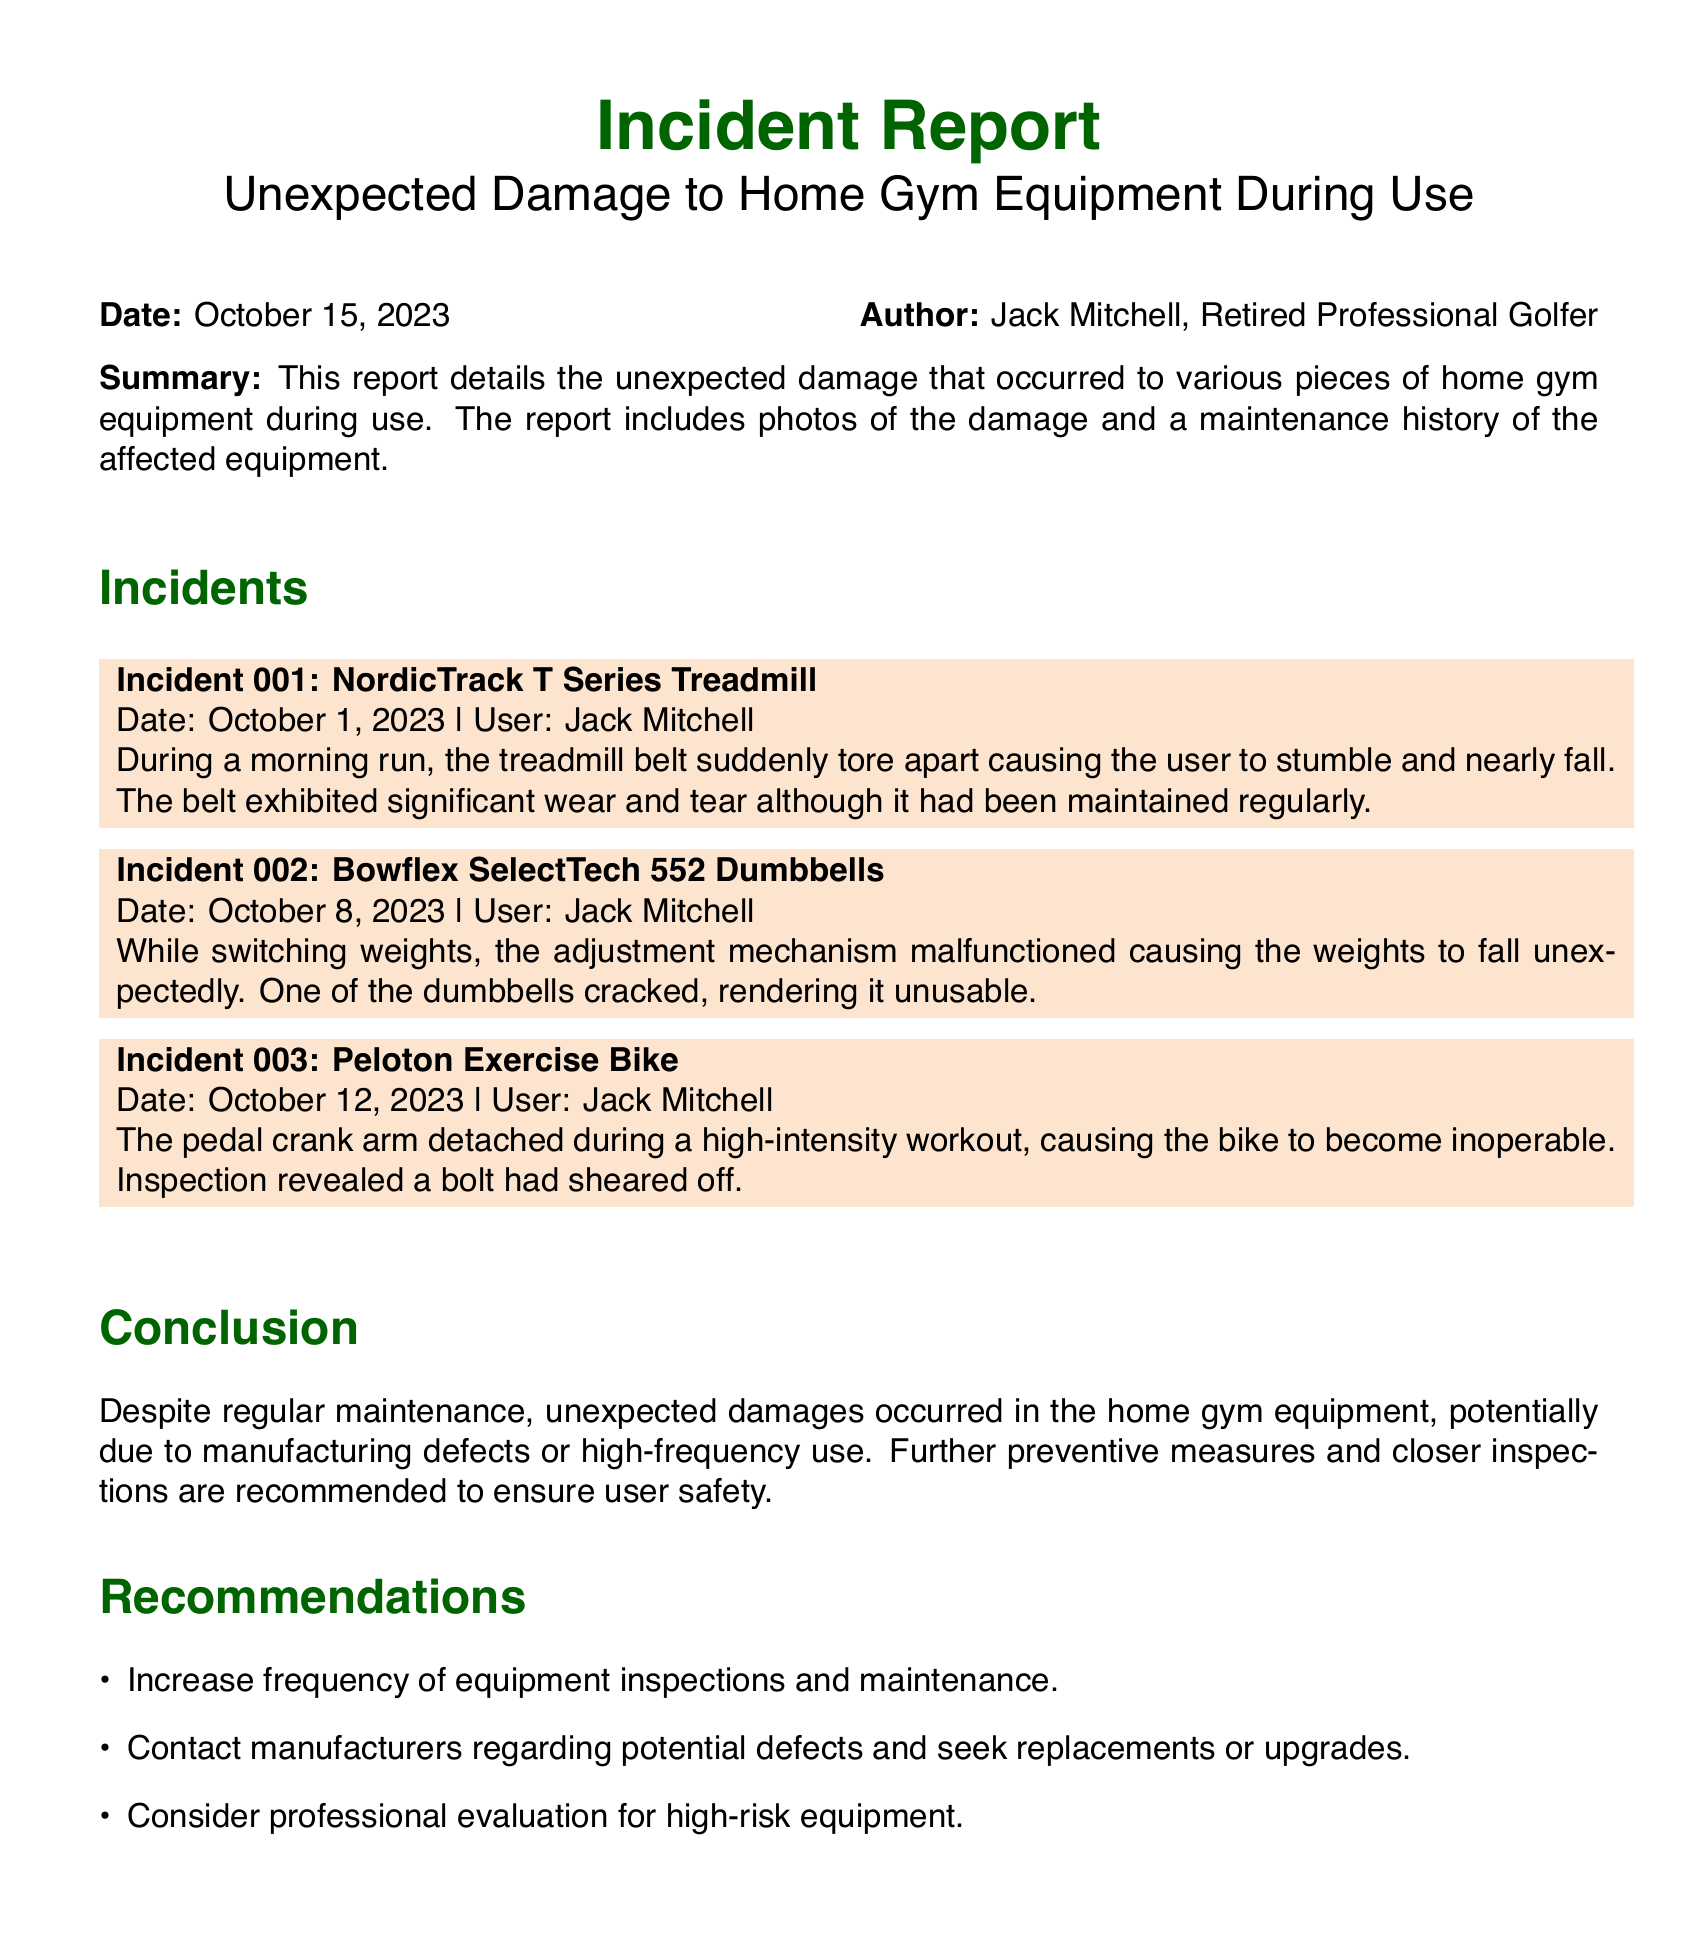What is the date of the first incident? The first incident involving the NordicTrack T Series Treadmill occurred on October 1, 2023.
Answer: October 1, 2023 Who is the author of the report? The report was authored by Jack Mitchell, who is a retired professional golfer.
Answer: Jack Mitchell What piece of equipment malfunctioned on October 8, 2023? On this date, the Bowflex SelectTech 552 Dumbbells experienced a malfunction in the adjustment mechanism.
Answer: Bowflex SelectTech 552 Dumbbells What was the issue with the Peloton Exercise Bike? The pedal crank arm detached during a high-intensity workout due to a sheared off bolt.
Answer: Pedal crank arm detached How many incidents are reported in total? The report details three separate incidents involving different gym equipment.
Answer: Three What is recommended to ensure user safety? One of the recommendations is to increase the frequency of equipment inspections and maintenance.
Answer: Increase frequency of equipment inspections When did the treadmill incident occur? The treadmill incident took place during a morning run on October 1, 2023.
Answer: October 1, 2023 How many pieces of gym equipment were affected by damage? There were three pieces of equipment that were reported to have damages in the incident report.
Answer: Three 